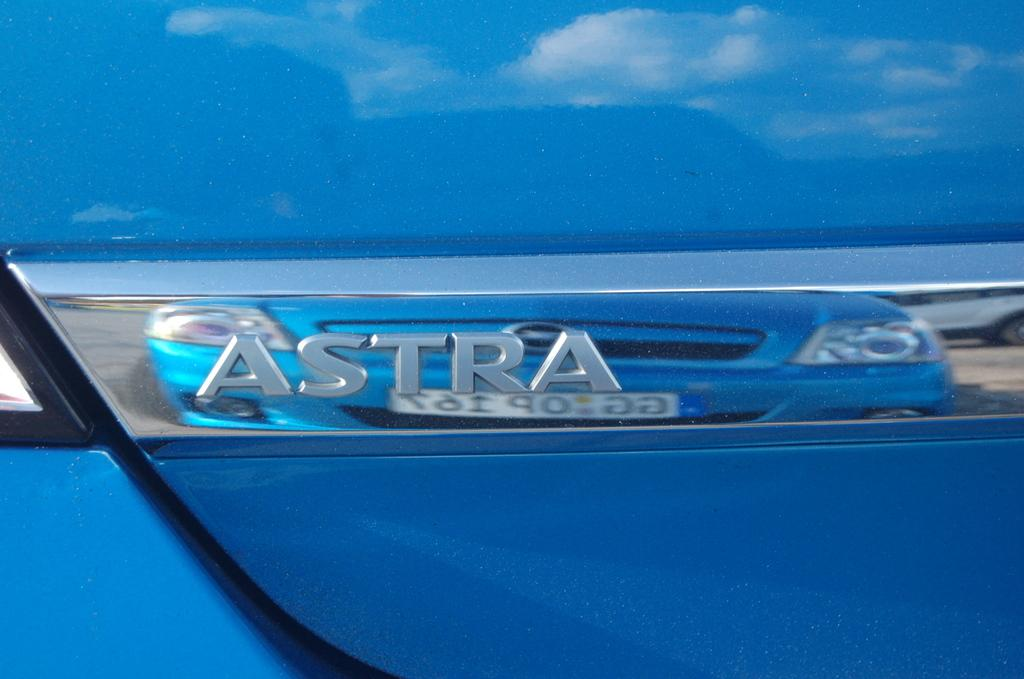What is the main subject of the picture? The main subject of the picture is a car. What can be observed about the car's appearance? The car has a logo and is blue. Is there any text or writing on the car? Yes, there is something written on the car. How much soda can be seen inside the car's tank in the image? There is no soda or tank present in the image; it features a car with a logo and writing. 